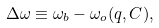Convert formula to latex. <formula><loc_0><loc_0><loc_500><loc_500>\Delta \omega \equiv \omega _ { b } - \omega _ { o } ( q , C ) ,</formula> 